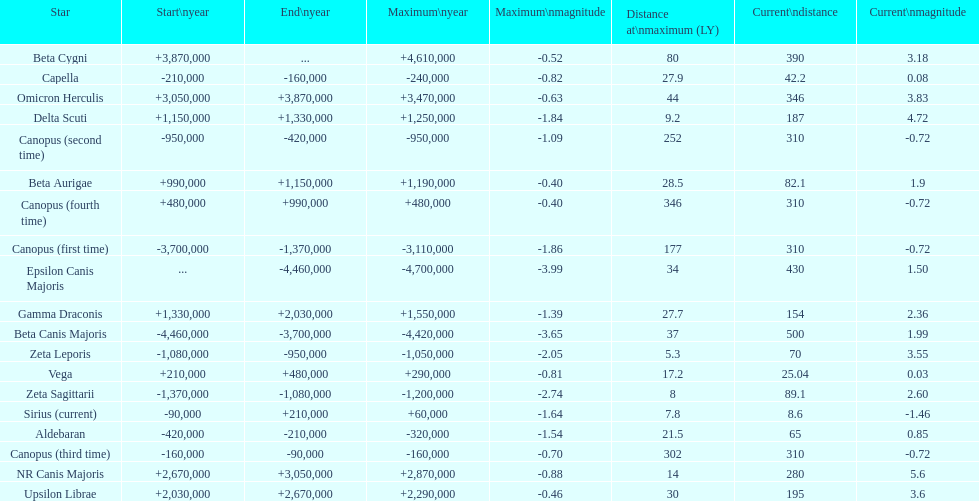How much farther (in ly) is epsilon canis majoris than zeta sagittarii? 26. 